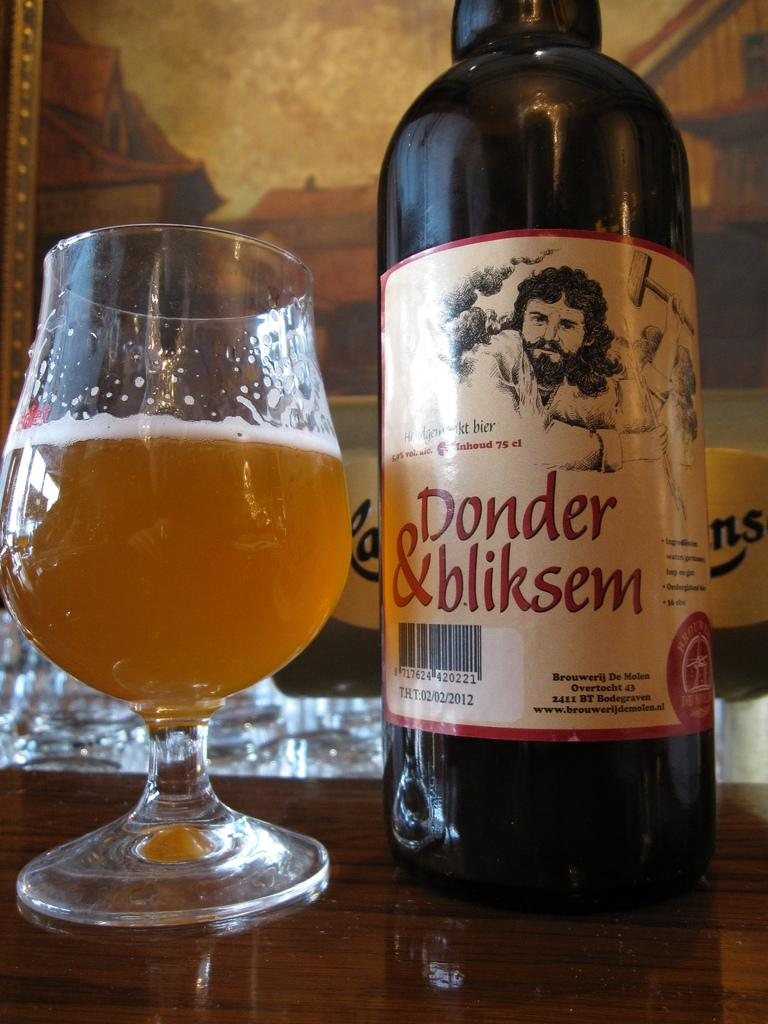<image>
Summarize the visual content of the image. A bottle of Donder and bliskem beer sits on a table next to a glass of beer. 